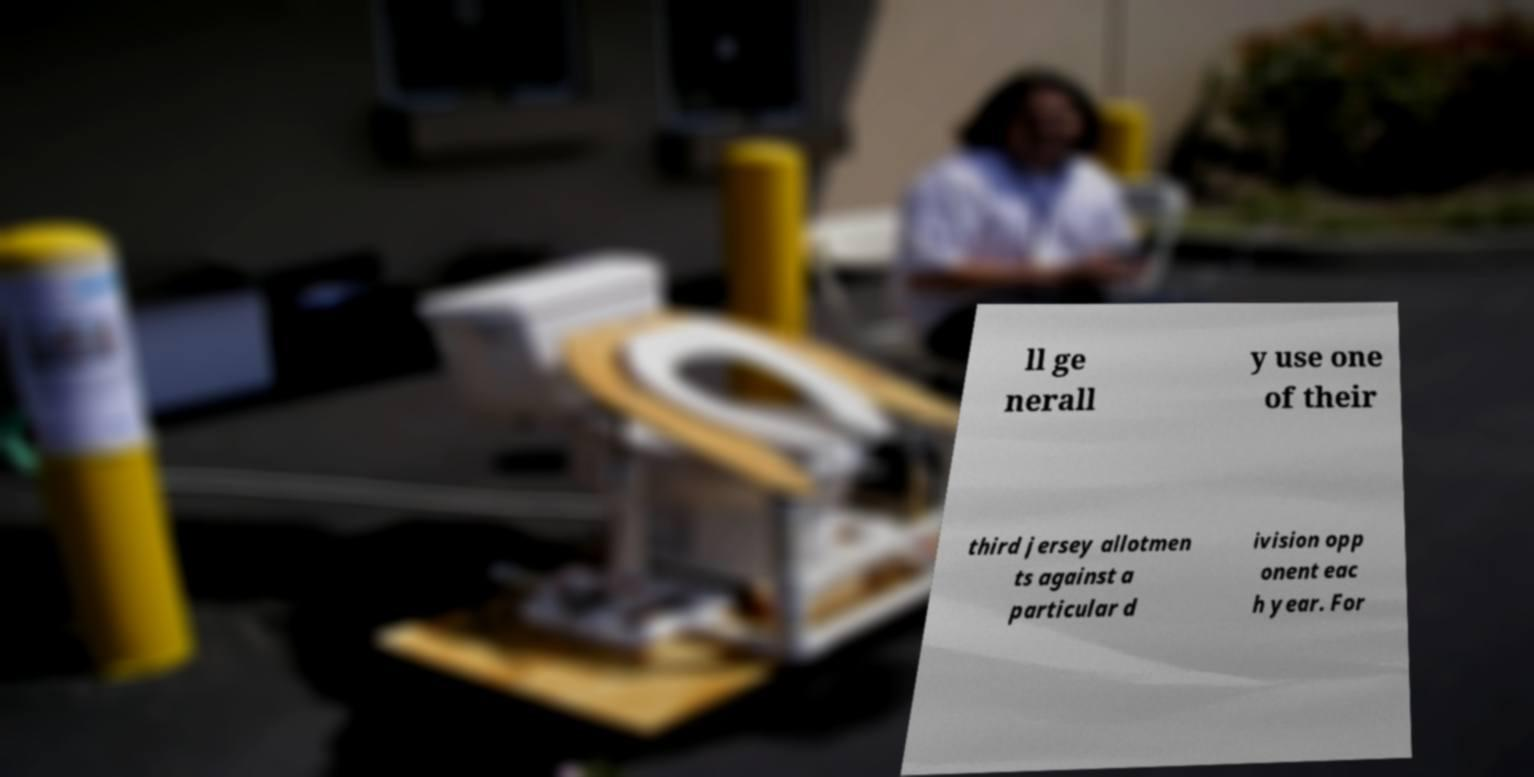Please identify and transcribe the text found in this image. ll ge nerall y use one of their third jersey allotmen ts against a particular d ivision opp onent eac h year. For 